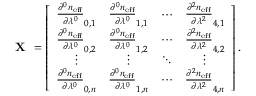<formula> <loc_0><loc_0><loc_500><loc_500>X = \left [ { \begin{array} { c c c c } { \frac { \partial ^ { 0 } n _ { e f f } } { \partial \lambda ^ { 0 } } _ { 0 , 1 } } & { \frac { \partial ^ { 0 } n _ { e f f } } { \partial \lambda ^ { 0 } } _ { 1 , 1 } } & { \cdots } & { \frac { \partial ^ { 2 } n _ { e f f } } { \partial \lambda ^ { 2 } } _ { 4 , 1 } } \\ { \frac { \partial ^ { 0 } n _ { e f f } } { \partial \lambda ^ { 0 } } _ { 0 , 2 } } & { \frac { \partial ^ { 0 } n _ { e f f } } { \partial \lambda ^ { 0 } } _ { 1 , 2 } } & { \cdots } & { \frac { \partial ^ { 2 } n _ { e f f } } { \partial \lambda ^ { 2 } } _ { 4 , 2 } } \\ { \vdots } & { \vdots } & { \ddots } & { \vdots } \\ { \frac { \partial ^ { 0 } n _ { e f f } } { \partial \lambda ^ { 0 } } _ { 0 , n } } & { \frac { \partial ^ { 0 } n _ { e f f } } { \partial \lambda ^ { 0 } } _ { 1 , n } } & { \cdots } & { \frac { \partial ^ { 2 } n _ { e f f } } { \partial \lambda ^ { 2 } } _ { 4 , n } } \end{array} } \right ] .</formula> 